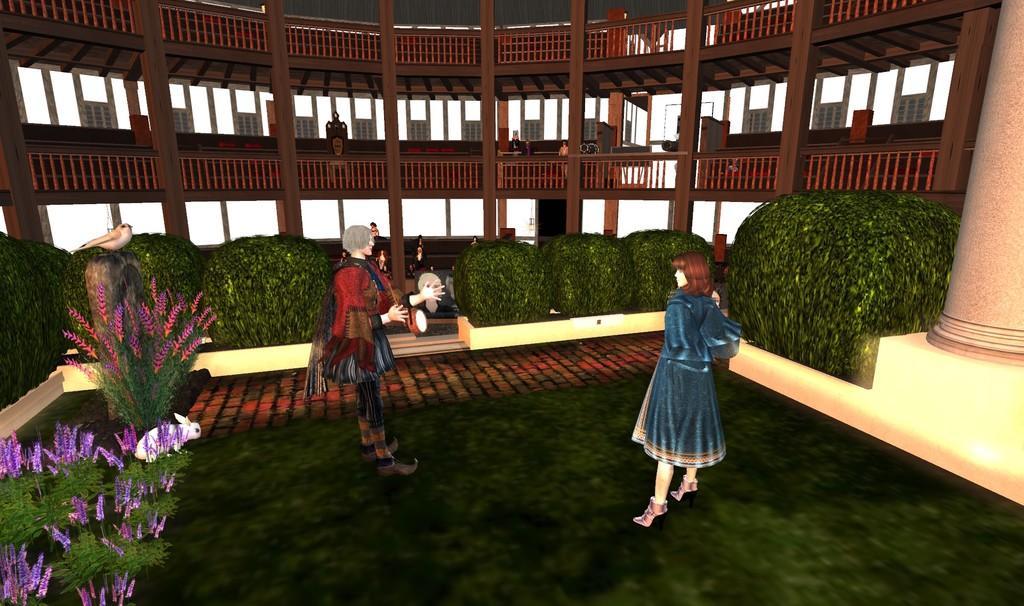Can you describe this image briefly? This is an animated picture. I can see group of people, there is a bird and a rabbit, there are plants and in the background there is a building. 